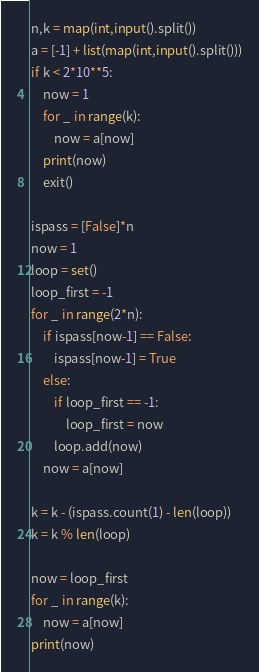<code> <loc_0><loc_0><loc_500><loc_500><_Python_>n,k = map(int,input().split())
a = [-1] + list(map(int,input().split()))
if k < 2*10**5:
    now = 1
    for _ in range(k):
        now = a[now]
    print(now)
    exit()

ispass = [False]*n
now = 1
loop = set()
loop_first = -1
for _ in range(2*n):
    if ispass[now-1] == False:
        ispass[now-1] = True
    else:
        if loop_first == -1:
            loop_first = now
        loop.add(now)
    now = a[now]

k = k - (ispass.count(1) - len(loop))
k = k % len(loop)

now = loop_first
for _ in range(k):
    now = a[now]
print(now)</code> 